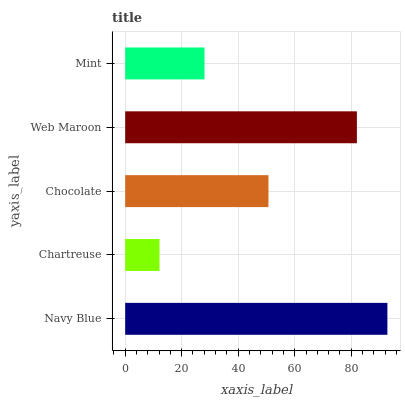Is Chartreuse the minimum?
Answer yes or no. Yes. Is Navy Blue the maximum?
Answer yes or no. Yes. Is Chocolate the minimum?
Answer yes or no. No. Is Chocolate the maximum?
Answer yes or no. No. Is Chocolate greater than Chartreuse?
Answer yes or no. Yes. Is Chartreuse less than Chocolate?
Answer yes or no. Yes. Is Chartreuse greater than Chocolate?
Answer yes or no. No. Is Chocolate less than Chartreuse?
Answer yes or no. No. Is Chocolate the high median?
Answer yes or no. Yes. Is Chocolate the low median?
Answer yes or no. Yes. Is Mint the high median?
Answer yes or no. No. Is Chartreuse the low median?
Answer yes or no. No. 